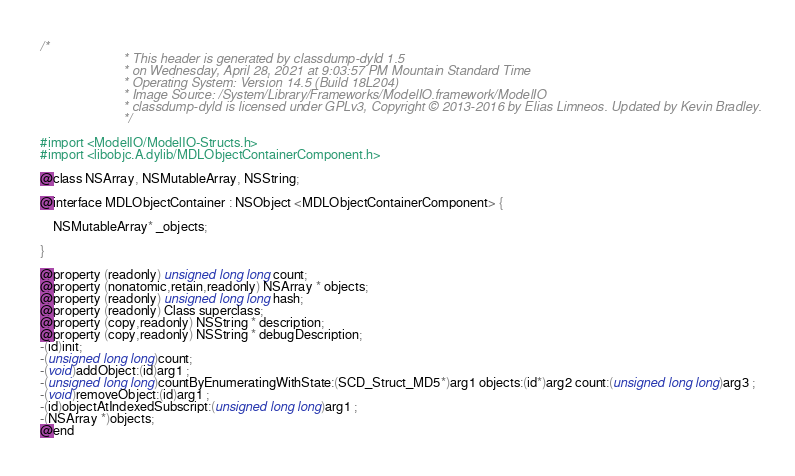<code> <loc_0><loc_0><loc_500><loc_500><_C_>/*
                       * This header is generated by classdump-dyld 1.5
                       * on Wednesday, April 28, 2021 at 9:03:57 PM Mountain Standard Time
                       * Operating System: Version 14.5 (Build 18L204)
                       * Image Source: /System/Library/Frameworks/ModelIO.framework/ModelIO
                       * classdump-dyld is licensed under GPLv3, Copyright © 2013-2016 by Elias Limneos. Updated by Kevin Bradley.
                       */

#import <ModelIO/ModelIO-Structs.h>
#import <libobjc.A.dylib/MDLObjectContainerComponent.h>

@class NSArray, NSMutableArray, NSString;

@interface MDLObjectContainer : NSObject <MDLObjectContainerComponent> {

	NSMutableArray* _objects;

}

@property (readonly) unsigned long long count; 
@property (nonatomic,retain,readonly) NSArray * objects; 
@property (readonly) unsigned long long hash; 
@property (readonly) Class superclass; 
@property (copy,readonly) NSString * description; 
@property (copy,readonly) NSString * debugDescription; 
-(id)init;
-(unsigned long long)count;
-(void)addObject:(id)arg1 ;
-(unsigned long long)countByEnumeratingWithState:(SCD_Struct_MD5*)arg1 objects:(id*)arg2 count:(unsigned long long)arg3 ;
-(void)removeObject:(id)arg1 ;
-(id)objectAtIndexedSubscript:(unsigned long long)arg1 ;
-(NSArray *)objects;
@end

</code> 